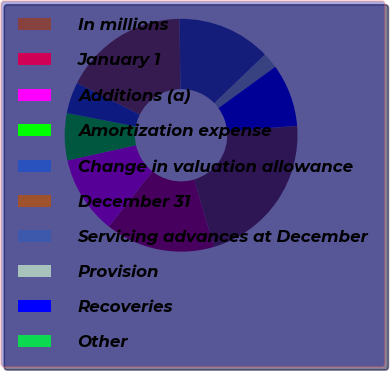Convert chart to OTSL. <chart><loc_0><loc_0><loc_500><loc_500><pie_chart><fcel>In millions<fcel>January 1<fcel>Additions (a)<fcel>Amortization expense<fcel>Change in valuation allowance<fcel>December 31<fcel>Servicing advances at December<fcel>Provision<fcel>Recoveries<fcel>Other<nl><fcel>21.73%<fcel>15.21%<fcel>10.87%<fcel>6.53%<fcel>4.35%<fcel>17.38%<fcel>13.04%<fcel>2.18%<fcel>8.7%<fcel>0.01%<nl></chart> 